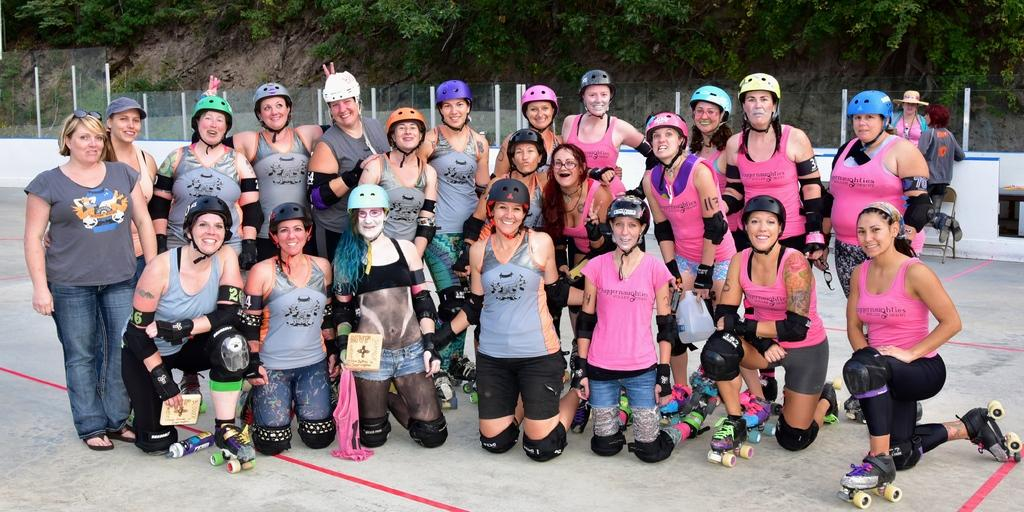What are the women in the image doing? There are women standing and sitting on the floor in the image. Can you describe the background of the image? In the background, there are people standing on the floor, chairs, fences, and trees are visible. How many women are standing in the image? The number of women standing is not specified, but there are women standing and sitting in the image. What type of stick is being used by the actor in the image? There is no actor or stick present in the image. What is the zinc content of the trees in the background? The zinc content of the trees cannot be determined from the image. 